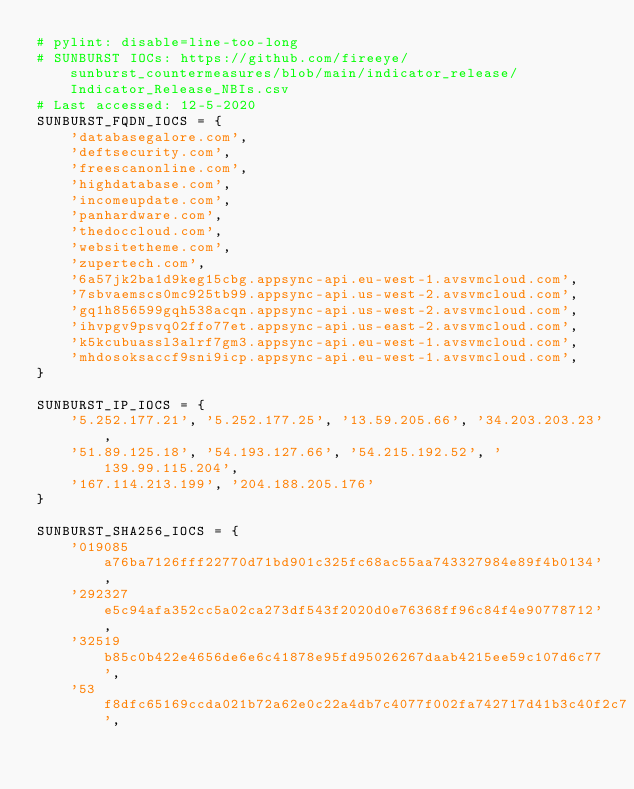Convert code to text. <code><loc_0><loc_0><loc_500><loc_500><_Python_># pylint: disable=line-too-long
# SUNBURST IOCs: https://github.com/fireeye/sunburst_countermeasures/blob/main/indicator_release/Indicator_Release_NBIs.csv
# Last accessed: 12-5-2020
SUNBURST_FQDN_IOCS = {
    'databasegalore.com',
    'deftsecurity.com',
    'freescanonline.com',
    'highdatabase.com',
    'incomeupdate.com',
    'panhardware.com',
    'thedoccloud.com',
    'websitetheme.com',
    'zupertech.com',
    '6a57jk2ba1d9keg15cbg.appsync-api.eu-west-1.avsvmcloud.com',
    '7sbvaemscs0mc925tb99.appsync-api.us-west-2.avsvmcloud.com',
    'gq1h856599gqh538acqn.appsync-api.us-west-2.avsvmcloud.com',
    'ihvpgv9psvq02ffo77et.appsync-api.us-east-2.avsvmcloud.com',
    'k5kcubuassl3alrf7gm3.appsync-api.eu-west-1.avsvmcloud.com',
    'mhdosoksaccf9sni9icp.appsync-api.eu-west-1.avsvmcloud.com',
}

SUNBURST_IP_IOCS = {
    '5.252.177.21', '5.252.177.25', '13.59.205.66', '34.203.203.23',
    '51.89.125.18', '54.193.127.66', '54.215.192.52', '139.99.115.204',
    '167.114.213.199', '204.188.205.176'
}

SUNBURST_SHA256_IOCS = {
    '019085a76ba7126fff22770d71bd901c325fc68ac55aa743327984e89f4b0134',
    '292327e5c94afa352cc5a02ca273df543f2020d0e76368ff96c84f4e90778712',
    '32519b85c0b422e4656de6e6c41878e95fd95026267daab4215ee59c107d6c77',
    '53f8dfc65169ccda021b72a62e0c22a4db7c4077f002fa742717d41b3c40f2c7',</code> 